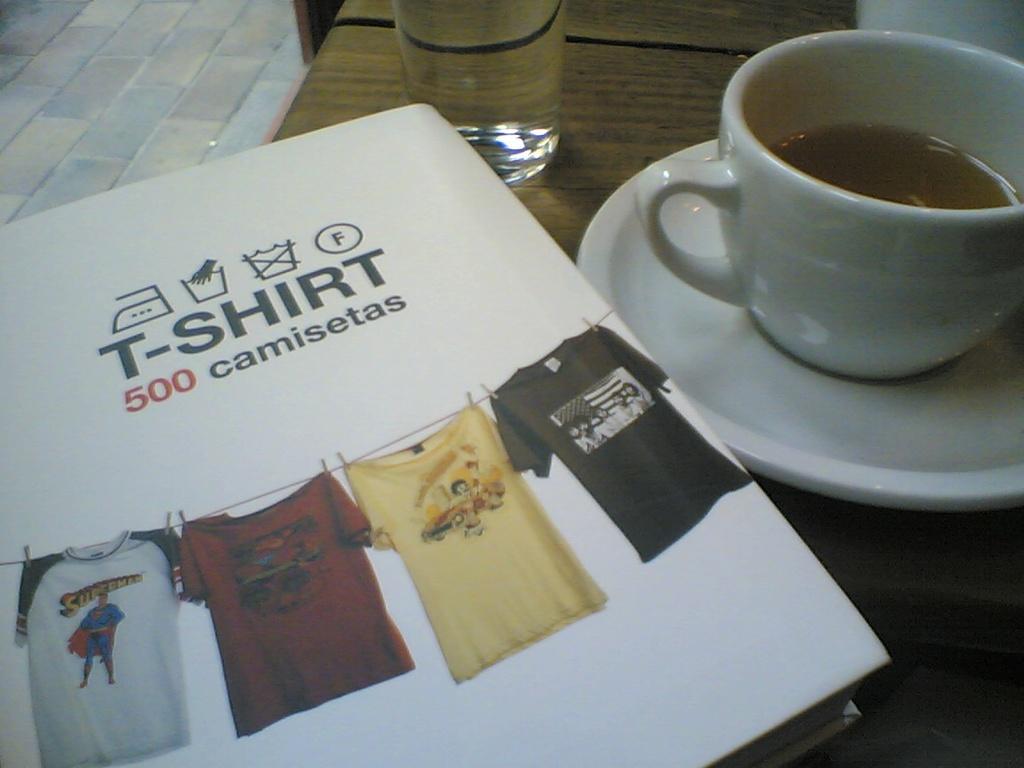How many camisetas are there?
Your response must be concise. 500. 